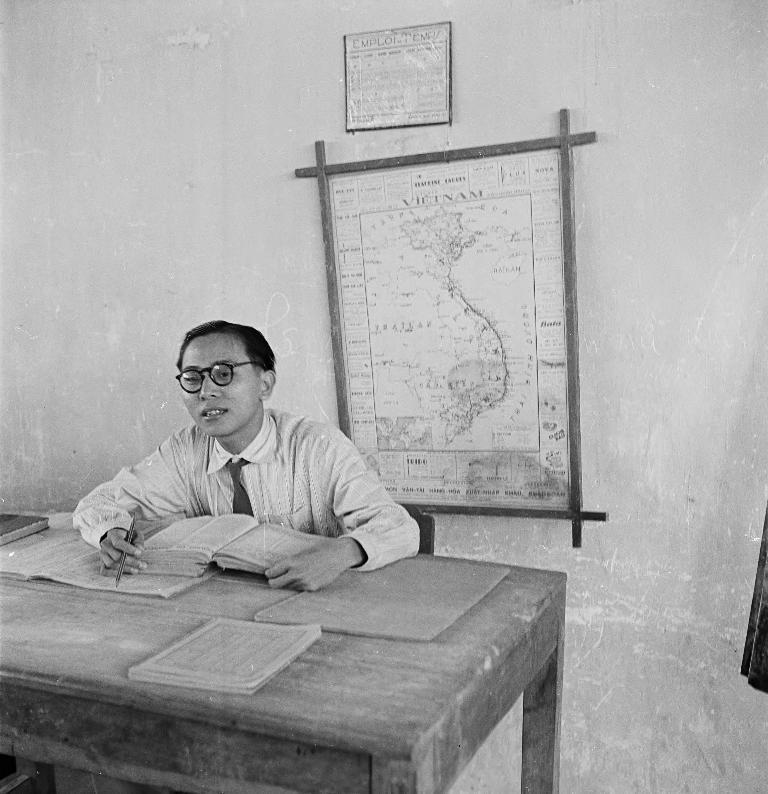How would you summarize this image in a sentence or two? It is a black and white picture where one person is sitting in the chair in front of the table and on the table there are books and a pen in his hands and behind him there is a big wall and there is the map placed on it and one picture on the map. 